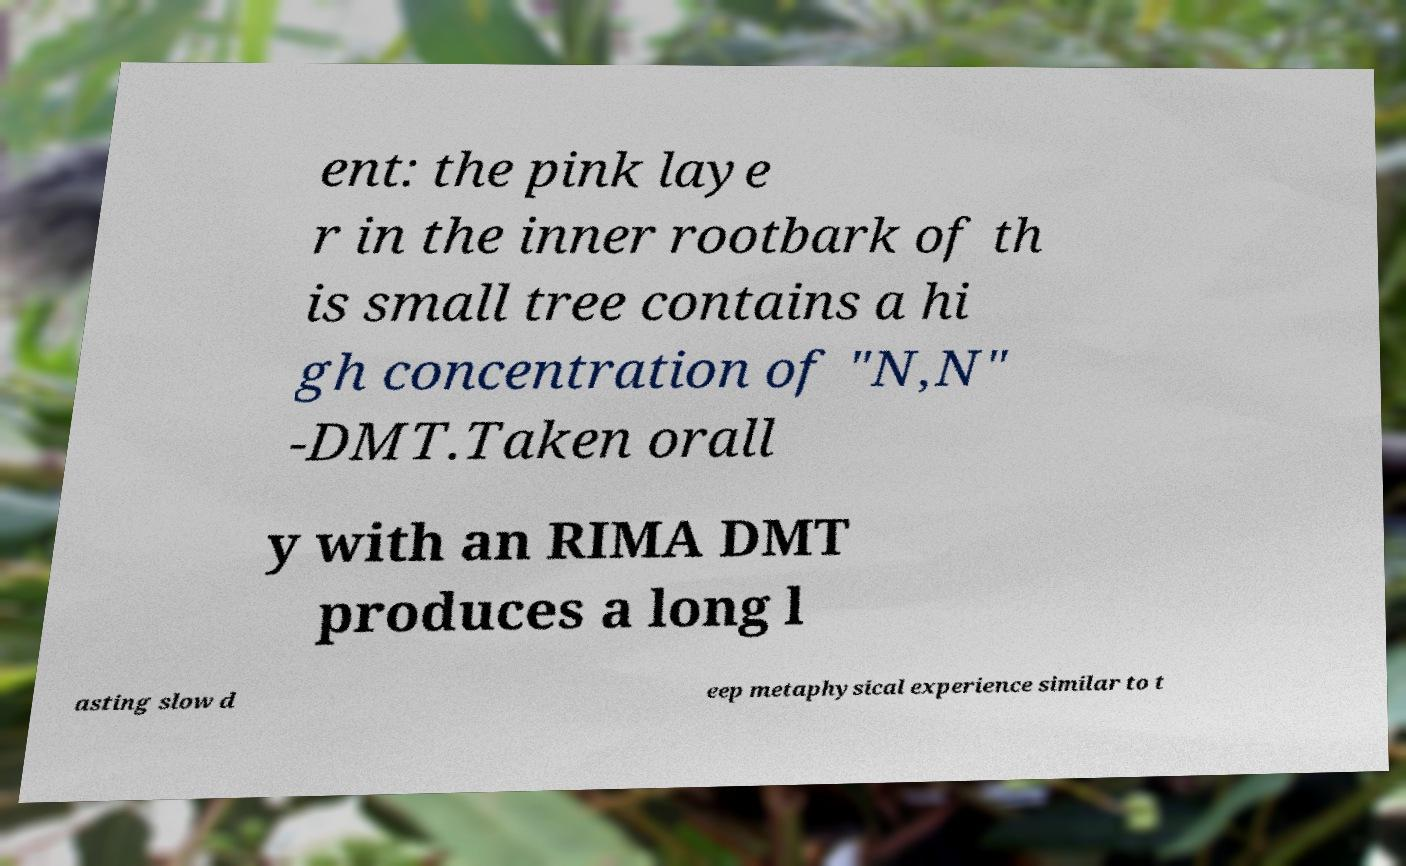Can you read and provide the text displayed in the image?This photo seems to have some interesting text. Can you extract and type it out for me? ent: the pink laye r in the inner rootbark of th is small tree contains a hi gh concentration of "N,N" -DMT.Taken orall y with an RIMA DMT produces a long l asting slow d eep metaphysical experience similar to t 